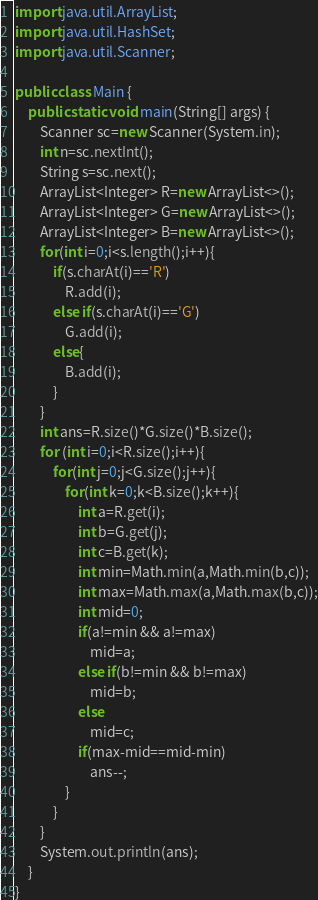Convert code to text. <code><loc_0><loc_0><loc_500><loc_500><_Java_>import java.util.ArrayList;
import java.util.HashSet;
import java.util.Scanner;

public class Main {
    public static void main(String[] args) {
        Scanner sc=new Scanner(System.in);
        int n=sc.nextInt();
        String s=sc.next();
        ArrayList<Integer> R=new ArrayList<>();
        ArrayList<Integer> G=new ArrayList<>();
        ArrayList<Integer> B=new ArrayList<>();
        for(int i=0;i<s.length();i++){
            if(s.charAt(i)=='R')
                R.add(i);
            else if(s.charAt(i)=='G')
                G.add(i);
            else{
                B.add(i);
            }
        }
        int ans=R.size()*G.size()*B.size();
        for (int i=0;i<R.size();i++){
            for(int j=0;j<G.size();j++){
                for(int k=0;k<B.size();k++){
                    int a=R.get(i);
                    int b=G.get(j);
                    int c=B.get(k);
                    int min=Math.min(a,Math.min(b,c));
                    int max=Math.max(a,Math.max(b,c));
                    int mid=0;
                    if(a!=min && a!=max)
                        mid=a;
                    else if(b!=min && b!=max)
                        mid=b;
                    else
                        mid=c;
                    if(max-mid==mid-min)
                        ans--;
                }
            }
        }
        System.out.println(ans);
    }
}
</code> 